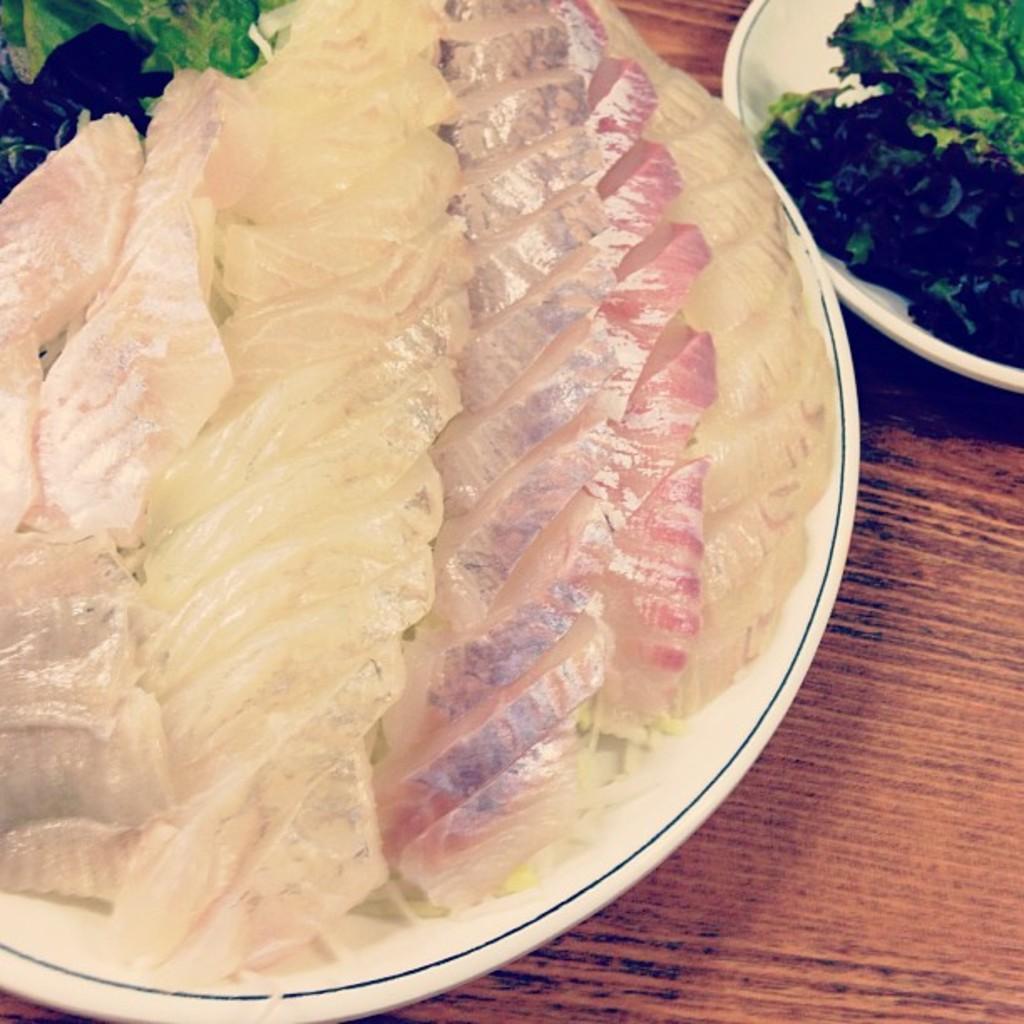Can you describe this image briefly? In this image I can see white colour plates and in these places I can see different types of food. I can see colour of this food is cream and green. 